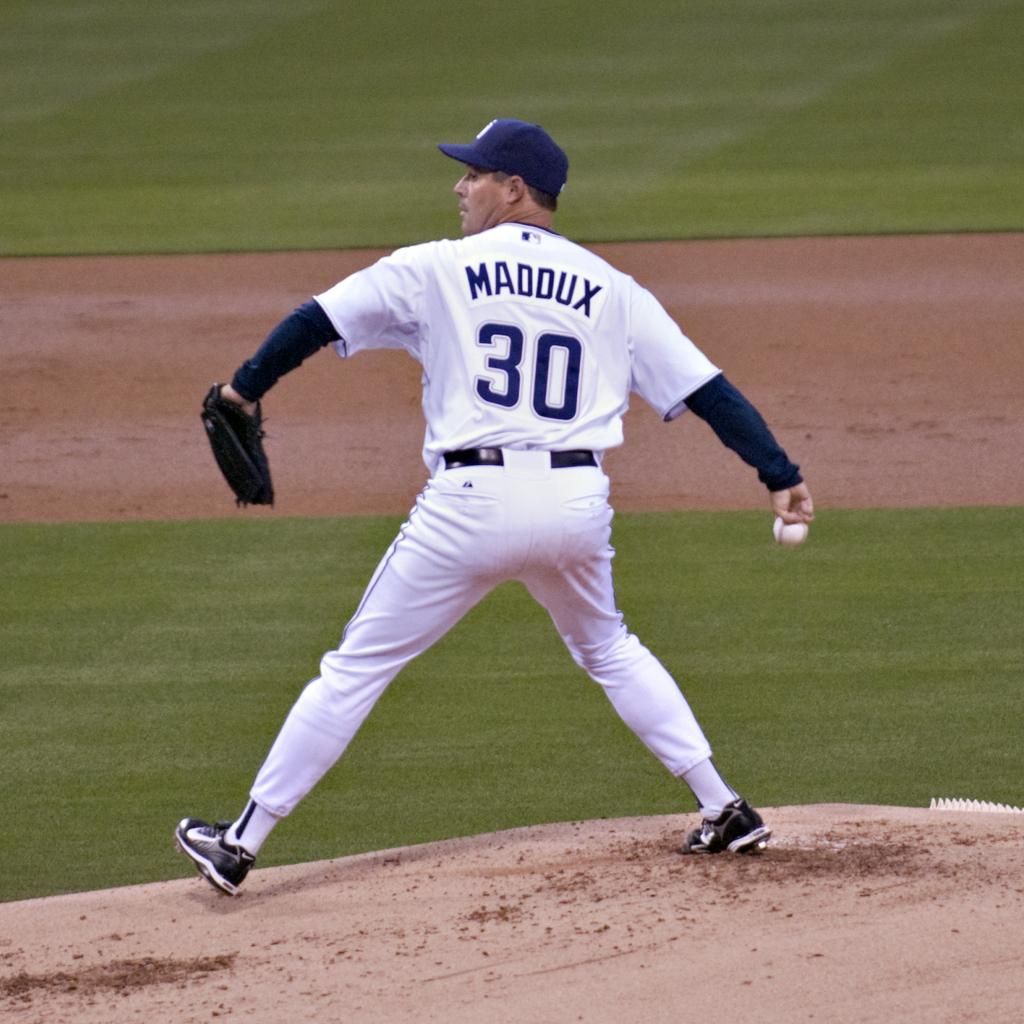Provide a one-sentence caption for the provided image. a man in a baseball uniform that says maddux #30 winds up his arm to throw a baseball. 